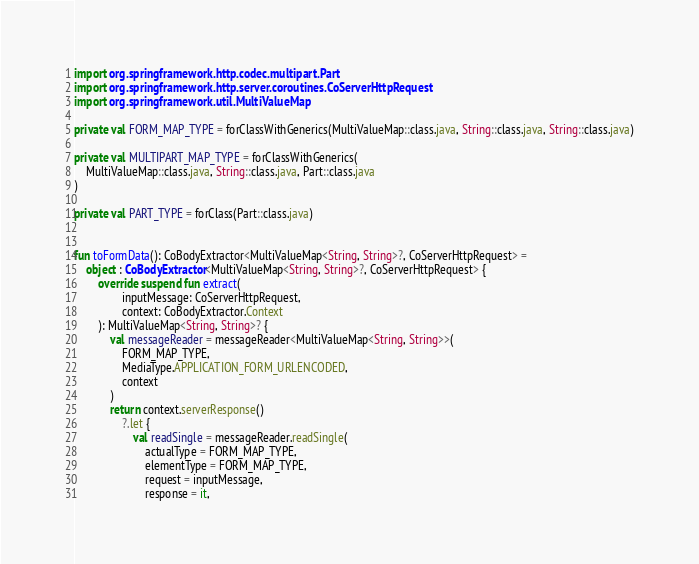<code> <loc_0><loc_0><loc_500><loc_500><_Kotlin_>import org.springframework.http.codec.multipart.Part
import org.springframework.http.server.coroutines.CoServerHttpRequest
import org.springframework.util.MultiValueMap

private val FORM_MAP_TYPE = forClassWithGenerics(MultiValueMap::class.java, String::class.java, String::class.java)

private val MULTIPART_MAP_TYPE = forClassWithGenerics(
	MultiValueMap::class.java, String::class.java, Part::class.java
)

private val PART_TYPE = forClass(Part::class.java)


fun toFormData(): CoBodyExtractor<MultiValueMap<String, String>?, CoServerHttpRequest> =
	object : CoBodyExtractor<MultiValueMap<String, String>?, CoServerHttpRequest> {
		override suspend fun extract(
				inputMessage: CoServerHttpRequest,
				context: CoBodyExtractor.Context
		): MultiValueMap<String, String>? {
			val messageReader = messageReader<MultiValueMap<String, String>>(
				FORM_MAP_TYPE,
				MediaType.APPLICATION_FORM_URLENCODED,
				context
			)
			return context.serverResponse()
				?.let {
					val readSingle = messageReader.readSingle(
						actualType = FORM_MAP_TYPE,
						elementType = FORM_MAP_TYPE,
						request = inputMessage,
						response = it,</code> 